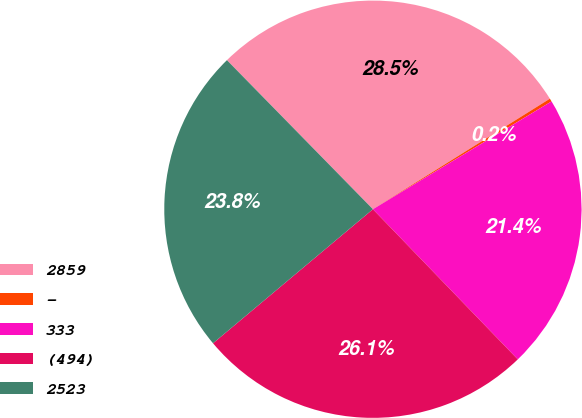Convert chart. <chart><loc_0><loc_0><loc_500><loc_500><pie_chart><fcel>2859<fcel>-<fcel>333<fcel>(494)<fcel>2523<nl><fcel>28.45%<fcel>0.24%<fcel>21.43%<fcel>26.11%<fcel>23.77%<nl></chart> 